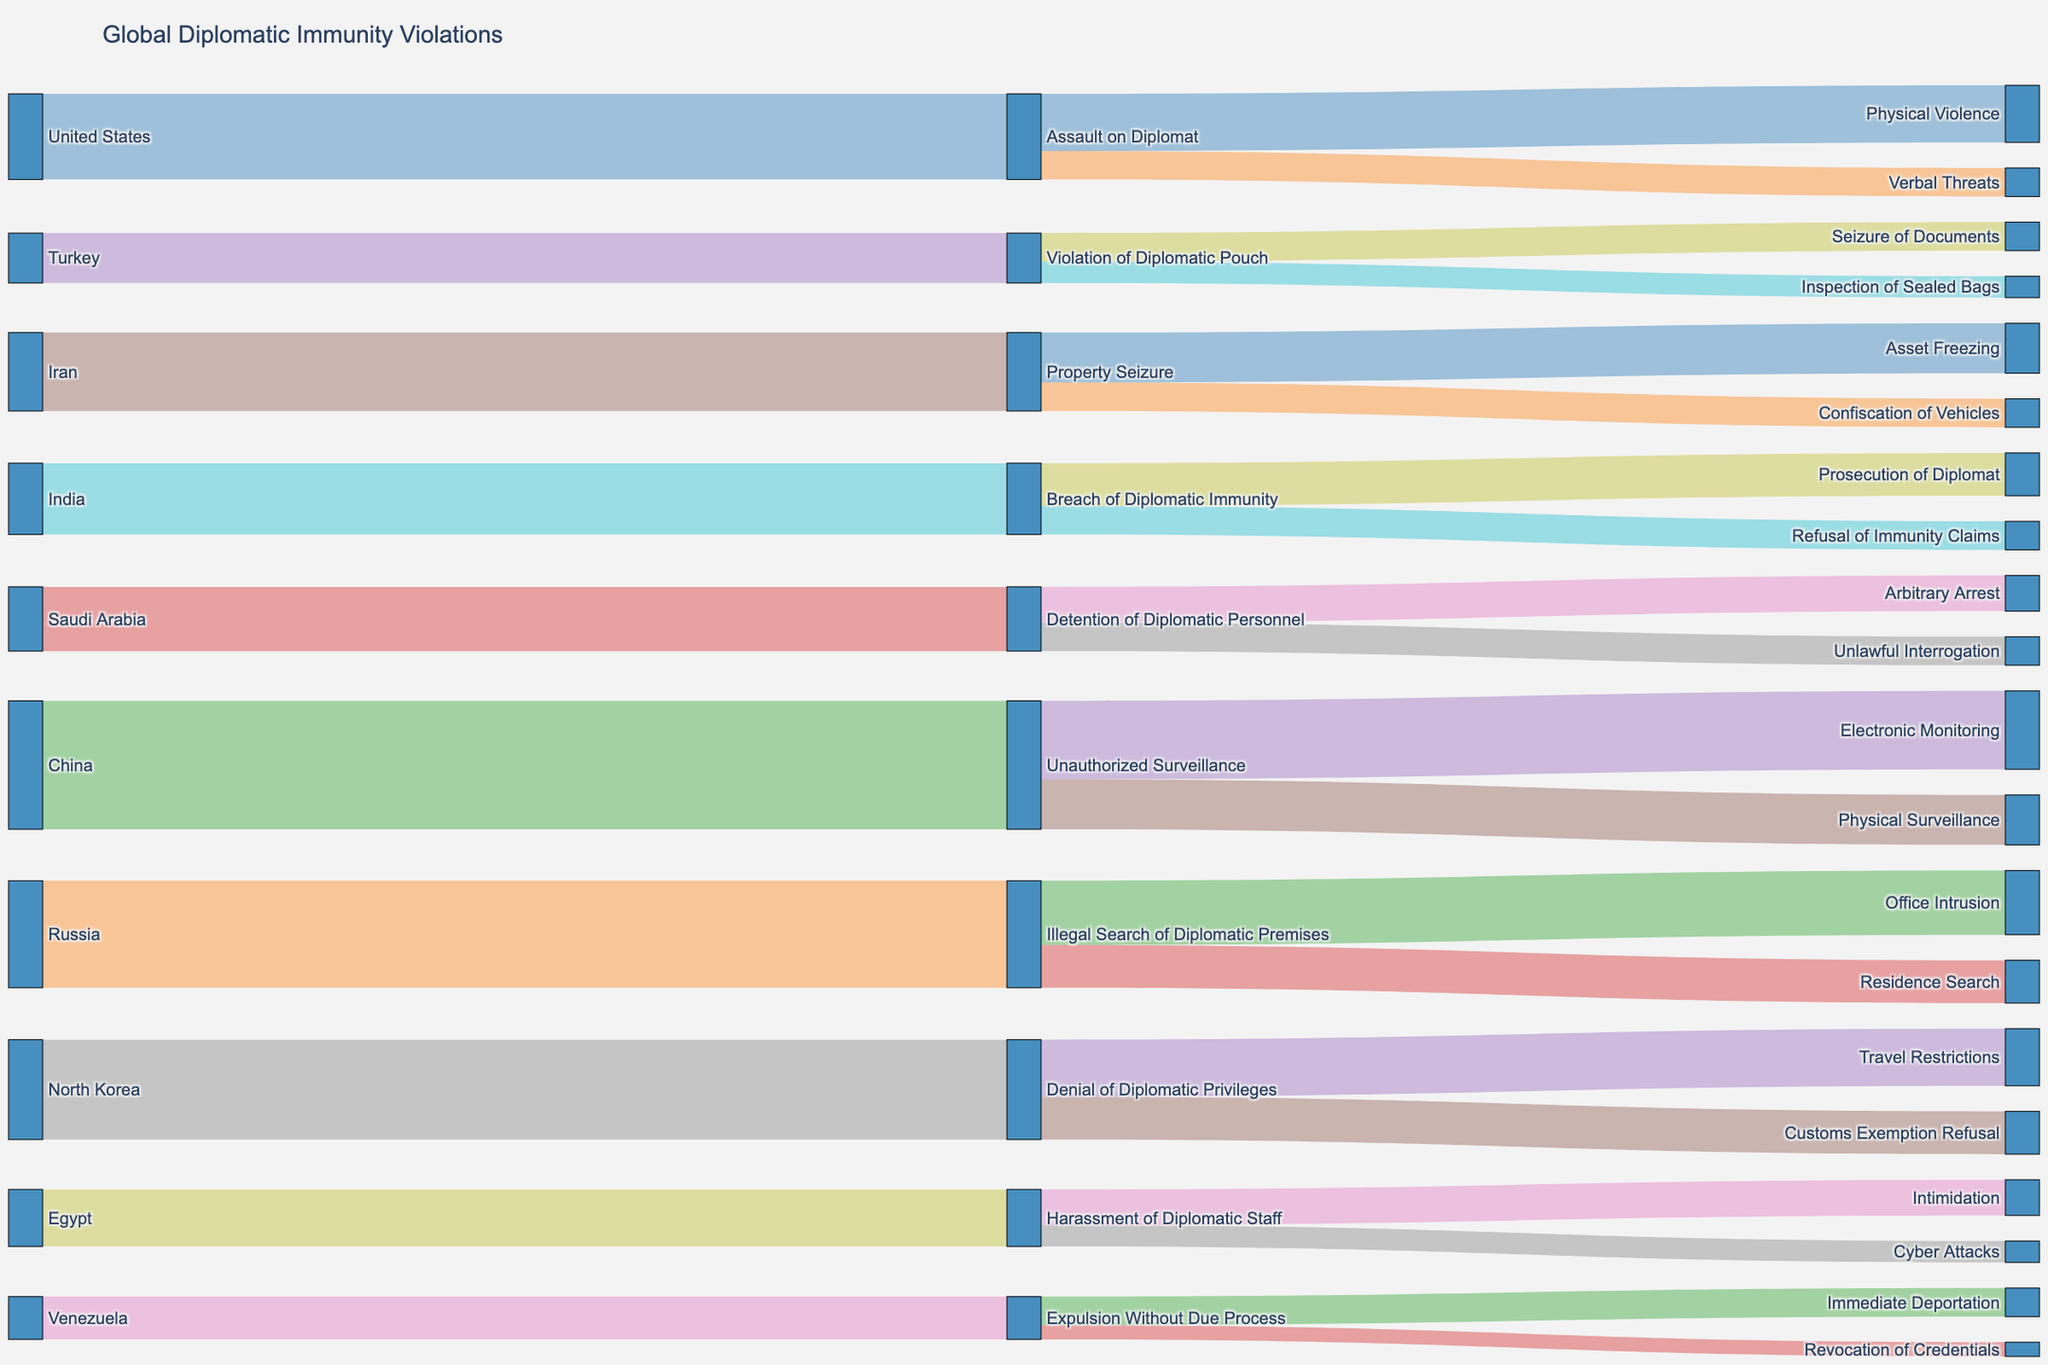What is the title of the Sankey diagram? The title is displayed at the top of the chart. It reads "Global Diplomatic Immunity Violations."
Answer: Global Diplomatic Immunity Violations Which country has the highest number of violations and what type is most violated? From the Sankey diagram, the country with the highest number of violations is China with "Unauthorized Surveillance" having 18 instances.
Answer: China, Unauthorized Surveillance How many total violations are reported for the "Unauthorized Surveillance" category? The chart shows two subcategories under "Unauthorized Surveillance": "Electronic Monitoring" (11) and "Physical Surveillance" (7). Adding them gives 11 + 7 = 18.
Answer: 18 Which violation type involves the greatest variety of subtypes? By looking at the links in the Sankey diagram, "Assault on Diplomat" has the highest variety with 2 subtypes: "Physical Violence" and "Verbal Threats."
Answer: Assault on Diplomat What is the total number of violations originating from the United States? The diagram shows 12 violations categorized under "Assault on Diplomat."
Answer: 12 Compare the number of "Detention of Diplomatic Personnel" violations to "Violation of Diplomatic Pouch" violations. Which has more and by how much? "Detention of Diplomatic Personnel" has 9 violations, while "Violation of Diplomatic Pouch" has 7. The difference is 9 - 7 = 2 violations.
Answer: Detention of Diplomatic Personnel by 2 How many subtypes exist under "Property Seizure" and what are their counts? Under "Property Seizure," there are two subtypes: "Asset Freezing" with 7 violations and "Confiscation of Vehicles" with 4 violations.
Answer: 2 subtypes: Asset Freezing (7), Confiscation of Vehicles (4) Identify the country with violations in "Breach of Diplomatic Immunity" and describe their types? "India" is the country with violations in this category. There are two types: "Prosecution of Diplomat" (6) and "Refusal of Immunity Claims" (4).
Answer: India: Prosecution of Diplomat (6), Refusal of Immunity Claims (4) Which type of violation has equal numbers for both subtypes and what are their counts? "Expulsion Without Due Process" has subtypes "Immediate Deportation" (4) and "Revocation of Credentials" (2), which are not equal. None of the violation types have equal numbers for both subtypes.
Answer: None Count the total violations originating from countries starting with the letter 'T'. Which countries are these? The countries starting with the letter 'T' are Turkey (7 violations) and Turkey specifically. There are 7 in total.
Answer: 7, Turkey 